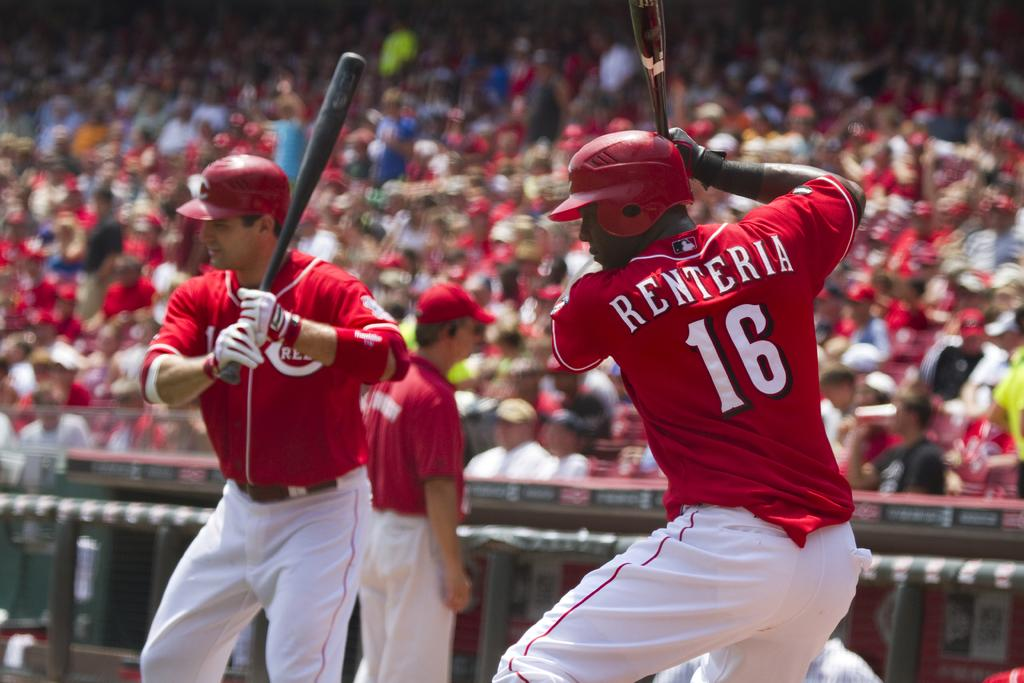<image>
Describe the image concisely. Baseball batters warming up in front of a crowd, one of them being Renteria number 16. 